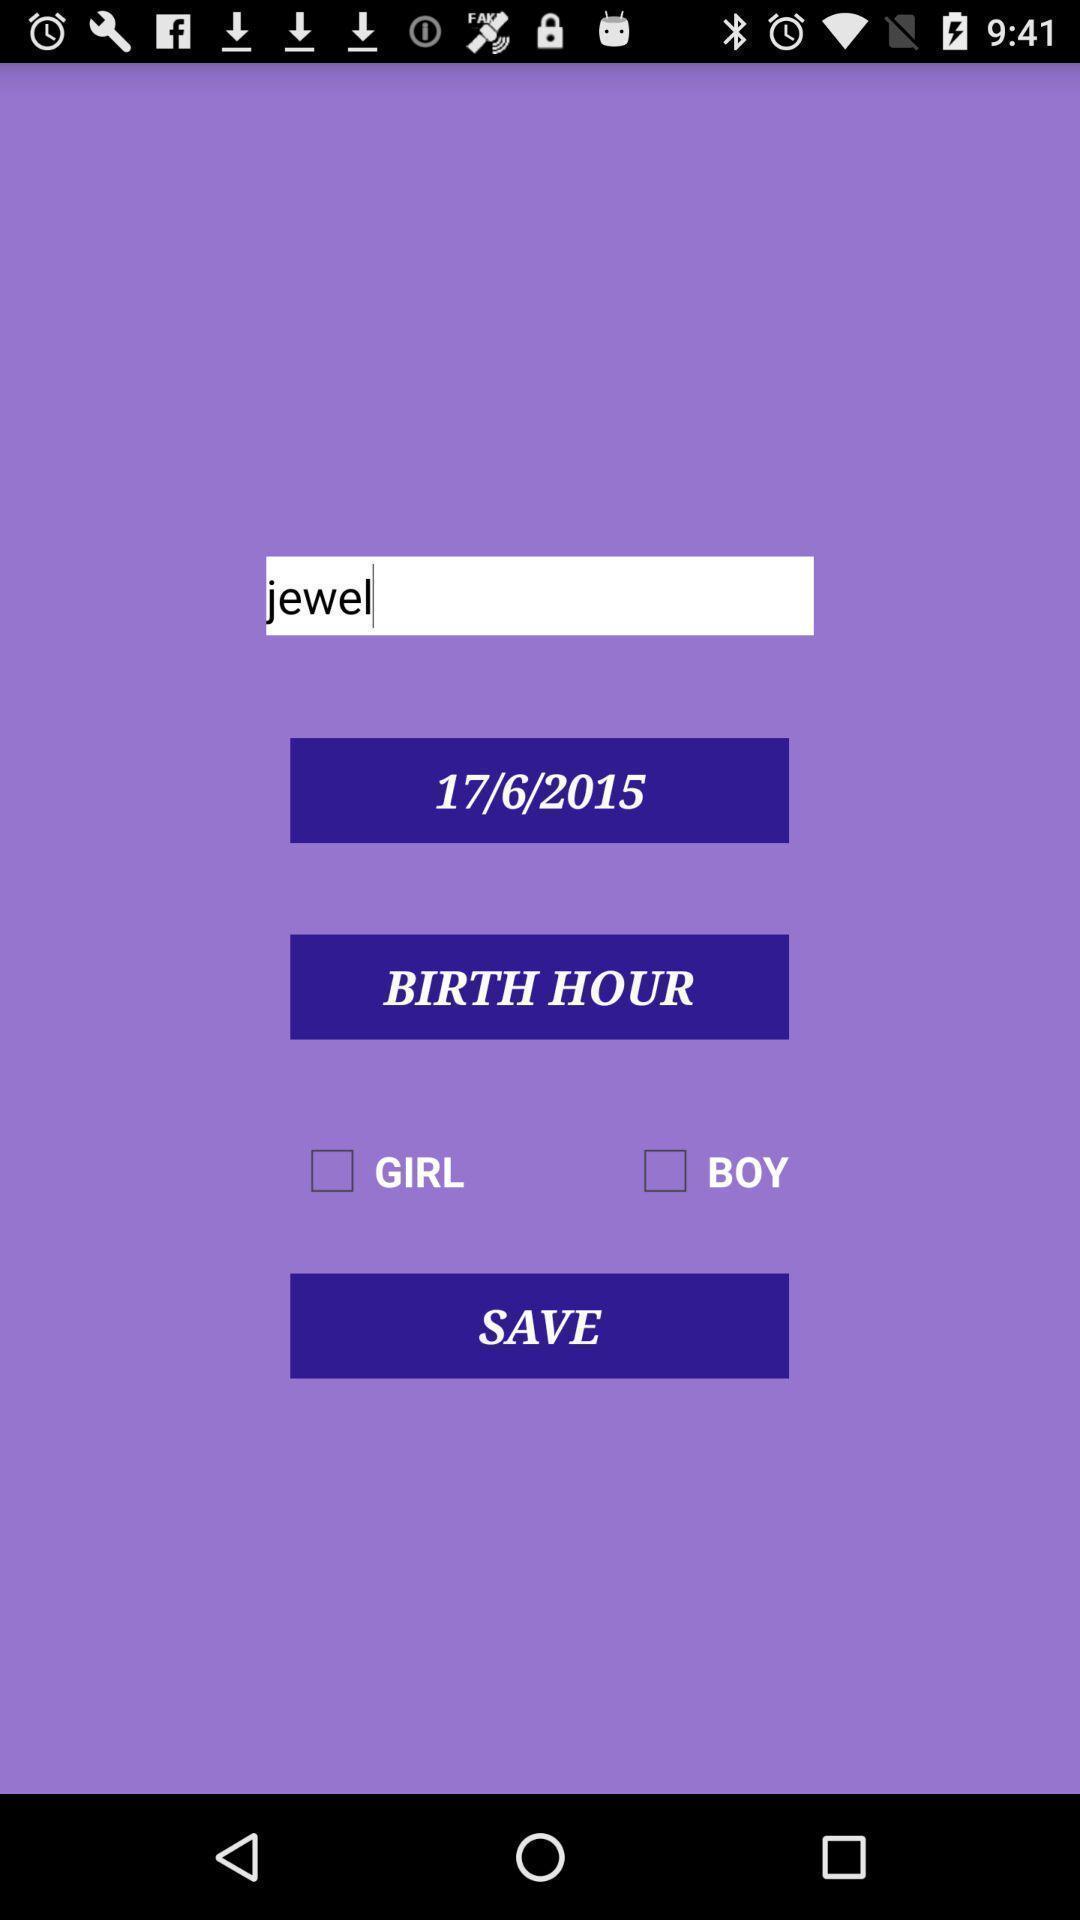Describe the content in this image. Screen displaying information about user. 